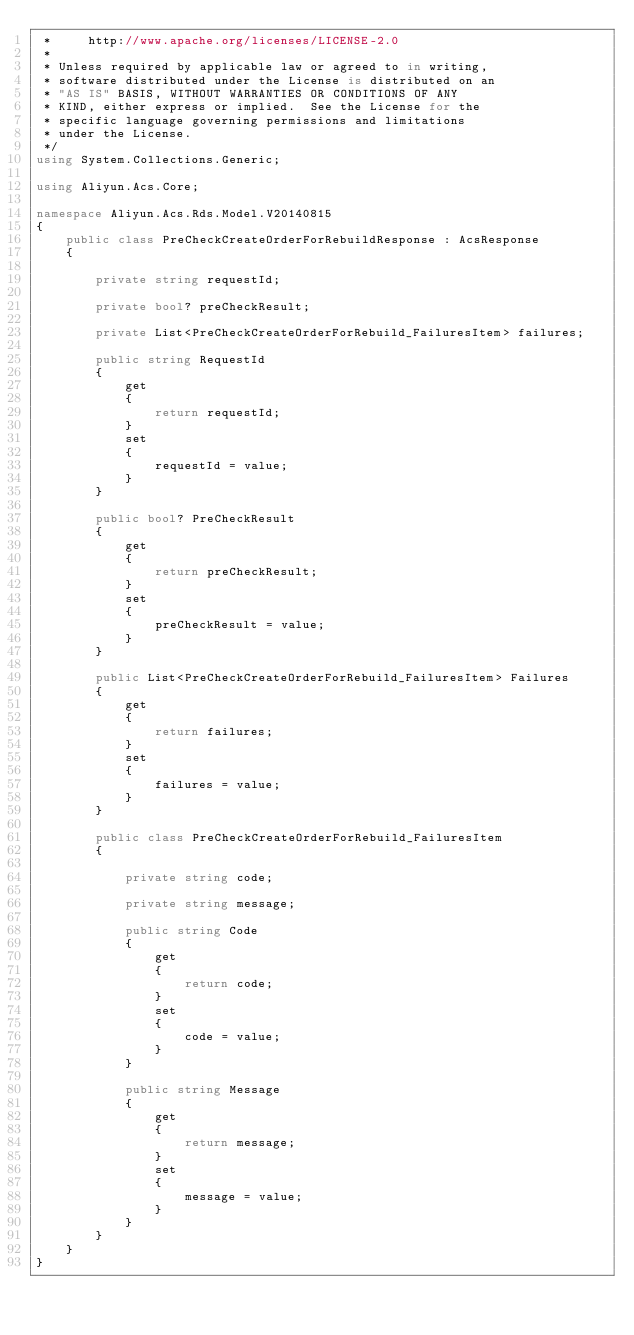<code> <loc_0><loc_0><loc_500><loc_500><_C#_> *     http://www.apache.org/licenses/LICENSE-2.0
 *
 * Unless required by applicable law or agreed to in writing,
 * software distributed under the License is distributed on an
 * "AS IS" BASIS, WITHOUT WARRANTIES OR CONDITIONS OF ANY
 * KIND, either express or implied.  See the License for the
 * specific language governing permissions and limitations
 * under the License.
 */
using System.Collections.Generic;

using Aliyun.Acs.Core;

namespace Aliyun.Acs.Rds.Model.V20140815
{
	public class PreCheckCreateOrderForRebuildResponse : AcsResponse
	{

		private string requestId;

		private bool? preCheckResult;

		private List<PreCheckCreateOrderForRebuild_FailuresItem> failures;

		public string RequestId
		{
			get
			{
				return requestId;
			}
			set	
			{
				requestId = value;
			}
		}

		public bool? PreCheckResult
		{
			get
			{
				return preCheckResult;
			}
			set	
			{
				preCheckResult = value;
			}
		}

		public List<PreCheckCreateOrderForRebuild_FailuresItem> Failures
		{
			get
			{
				return failures;
			}
			set	
			{
				failures = value;
			}
		}

		public class PreCheckCreateOrderForRebuild_FailuresItem
		{

			private string code;

			private string message;

			public string Code
			{
				get
				{
					return code;
				}
				set	
				{
					code = value;
				}
			}

			public string Message
			{
				get
				{
					return message;
				}
				set	
				{
					message = value;
				}
			}
		}
	}
}
</code> 